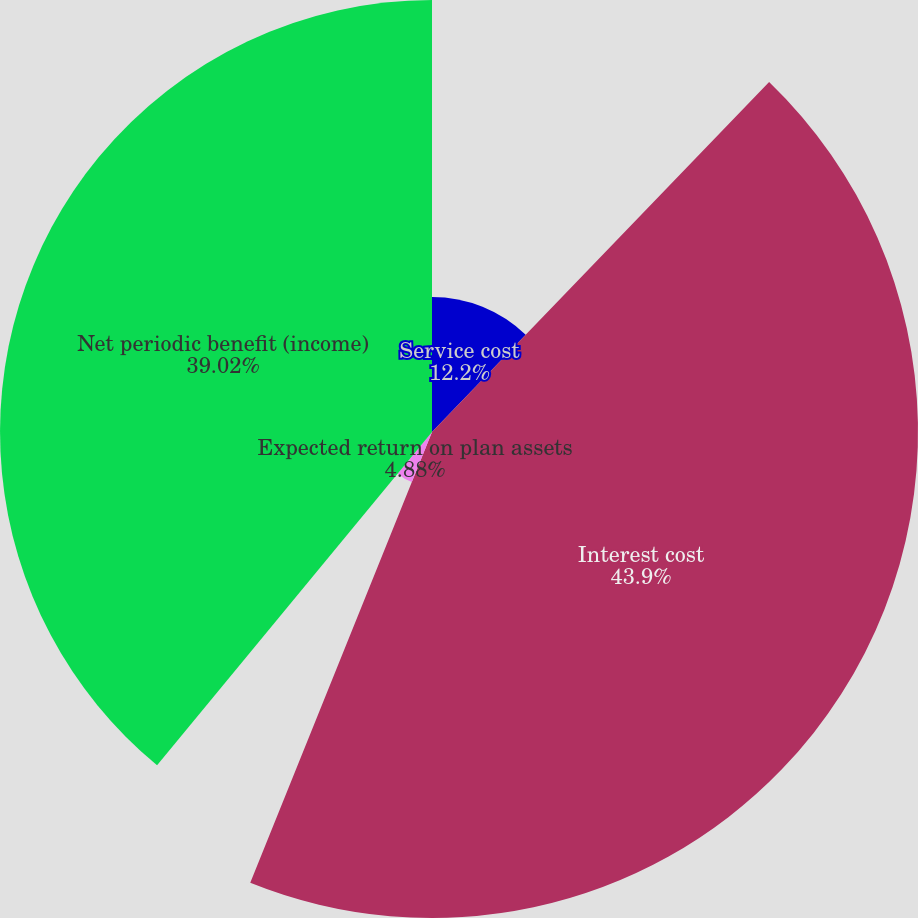Convert chart. <chart><loc_0><loc_0><loc_500><loc_500><pie_chart><fcel>Service cost<fcel>Interest cost<fcel>Expected return on plan assets<fcel>Net periodic benefit (income)<nl><fcel>12.2%<fcel>43.9%<fcel>4.88%<fcel>39.02%<nl></chart> 